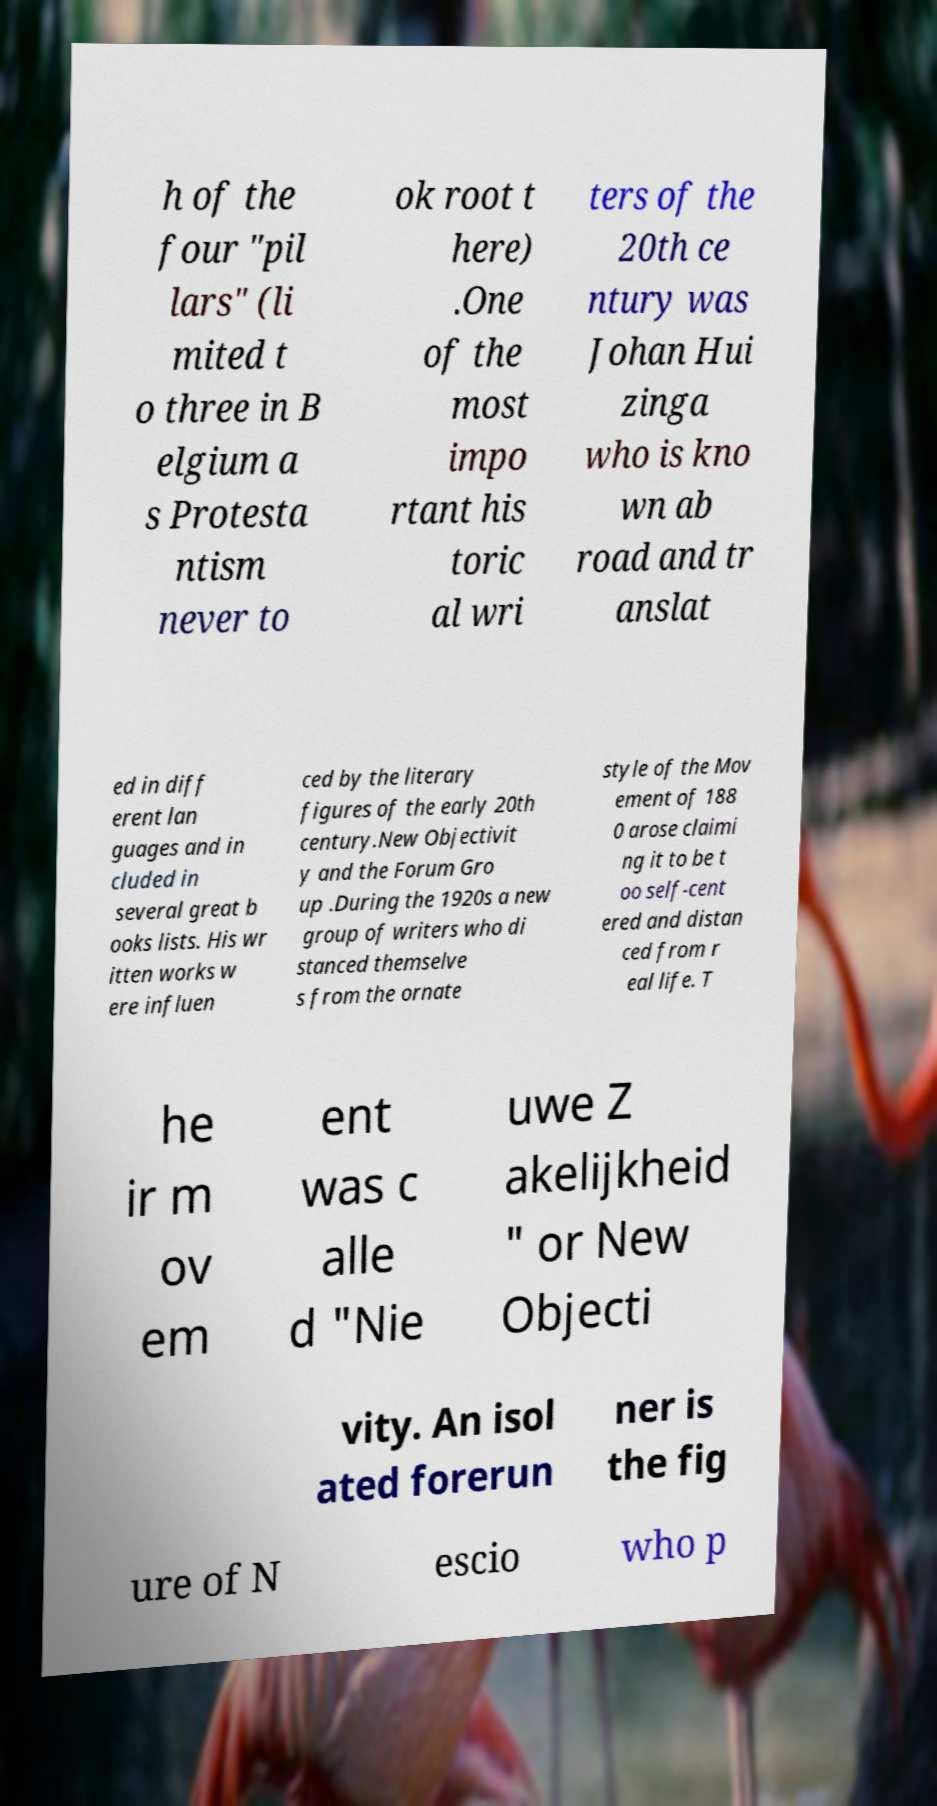Can you accurately transcribe the text from the provided image for me? h of the four "pil lars" (li mited t o three in B elgium a s Protesta ntism never to ok root t here) .One of the most impo rtant his toric al wri ters of the 20th ce ntury was Johan Hui zinga who is kno wn ab road and tr anslat ed in diff erent lan guages and in cluded in several great b ooks lists. His wr itten works w ere influen ced by the literary figures of the early 20th century.New Objectivit y and the Forum Gro up .During the 1920s a new group of writers who di stanced themselve s from the ornate style of the Mov ement of 188 0 arose claimi ng it to be t oo self-cent ered and distan ced from r eal life. T he ir m ov em ent was c alle d "Nie uwe Z akelijkheid " or New Objecti vity. An isol ated forerun ner is the fig ure of N escio who p 